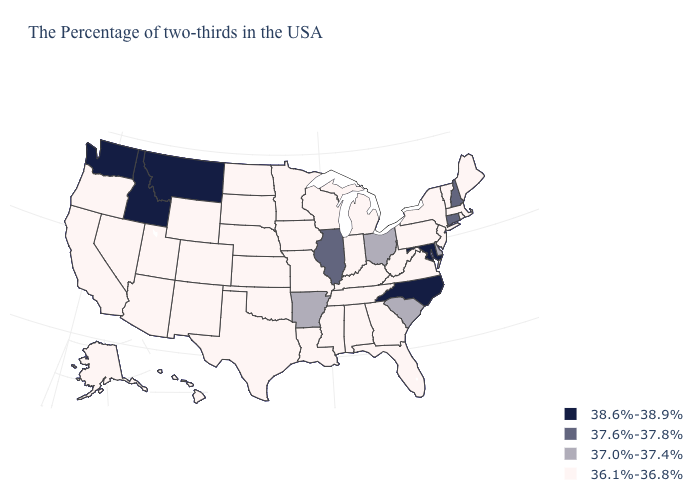Does Idaho have the lowest value in the USA?
Write a very short answer. No. What is the value of Michigan?
Keep it brief. 36.1%-36.8%. Does Ohio have the same value as South Carolina?
Be succinct. Yes. Does Wyoming have the same value as Connecticut?
Write a very short answer. No. Which states have the lowest value in the MidWest?
Be succinct. Michigan, Indiana, Wisconsin, Missouri, Minnesota, Iowa, Kansas, Nebraska, South Dakota, North Dakota. What is the lowest value in the South?
Concise answer only. 36.1%-36.8%. Name the states that have a value in the range 37.6%-37.8%?
Give a very brief answer. New Hampshire, Connecticut, Illinois. Does the map have missing data?
Answer briefly. No. What is the lowest value in states that border Georgia?
Answer briefly. 36.1%-36.8%. What is the value of Maine?
Answer briefly. 36.1%-36.8%. What is the lowest value in the West?
Keep it brief. 36.1%-36.8%. What is the value of Virginia?
Write a very short answer. 36.1%-36.8%. What is the highest value in the Northeast ?
Give a very brief answer. 37.6%-37.8%. How many symbols are there in the legend?
Be succinct. 4. Does Maryland have the highest value in the USA?
Be succinct. Yes. 